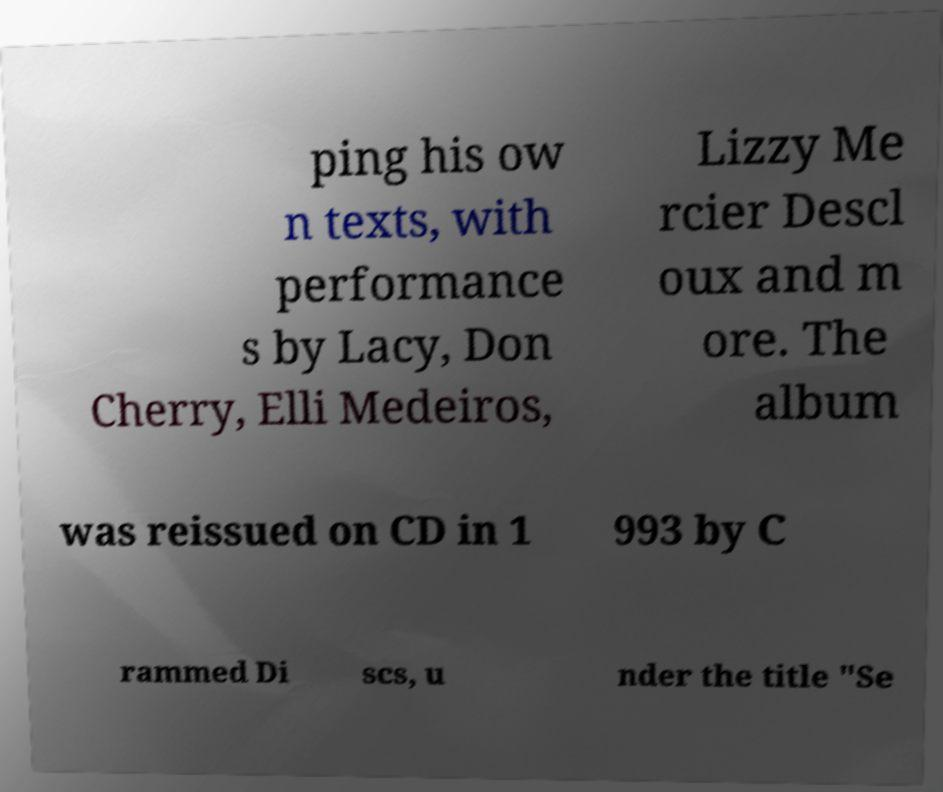What messages or text are displayed in this image? I need them in a readable, typed format. ping his ow n texts, with performance s by Lacy, Don Cherry, Elli Medeiros, Lizzy Me rcier Descl oux and m ore. The album was reissued on CD in 1 993 by C rammed Di scs, u nder the title "Se 